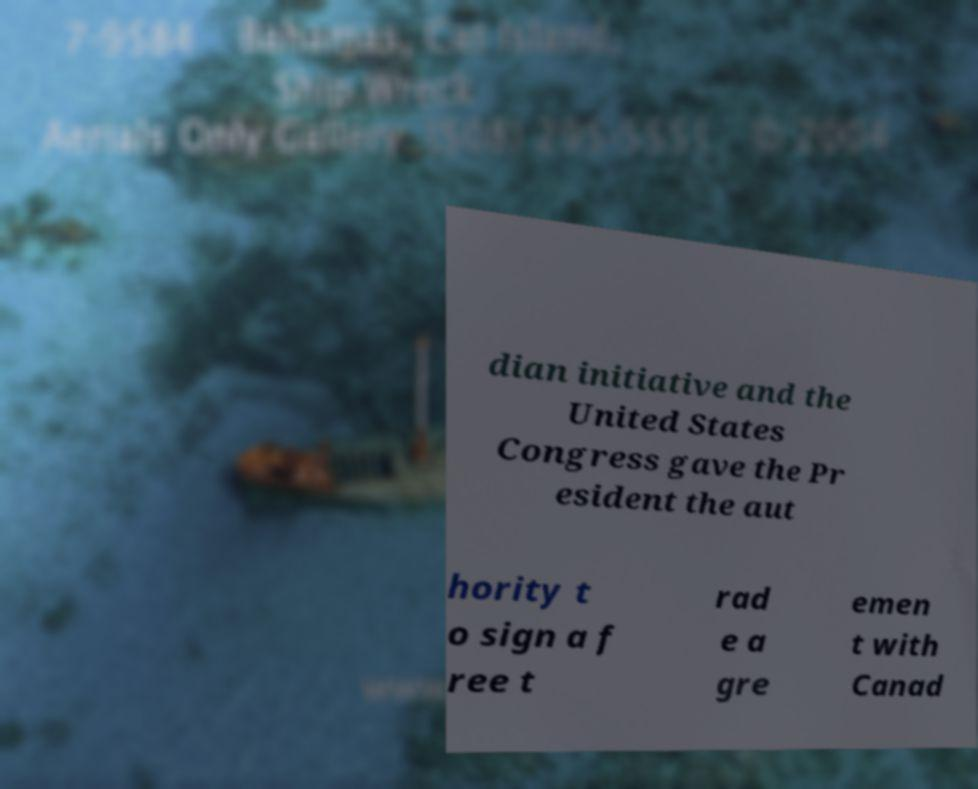Please identify and transcribe the text found in this image. dian initiative and the United States Congress gave the Pr esident the aut hority t o sign a f ree t rad e a gre emen t with Canad 